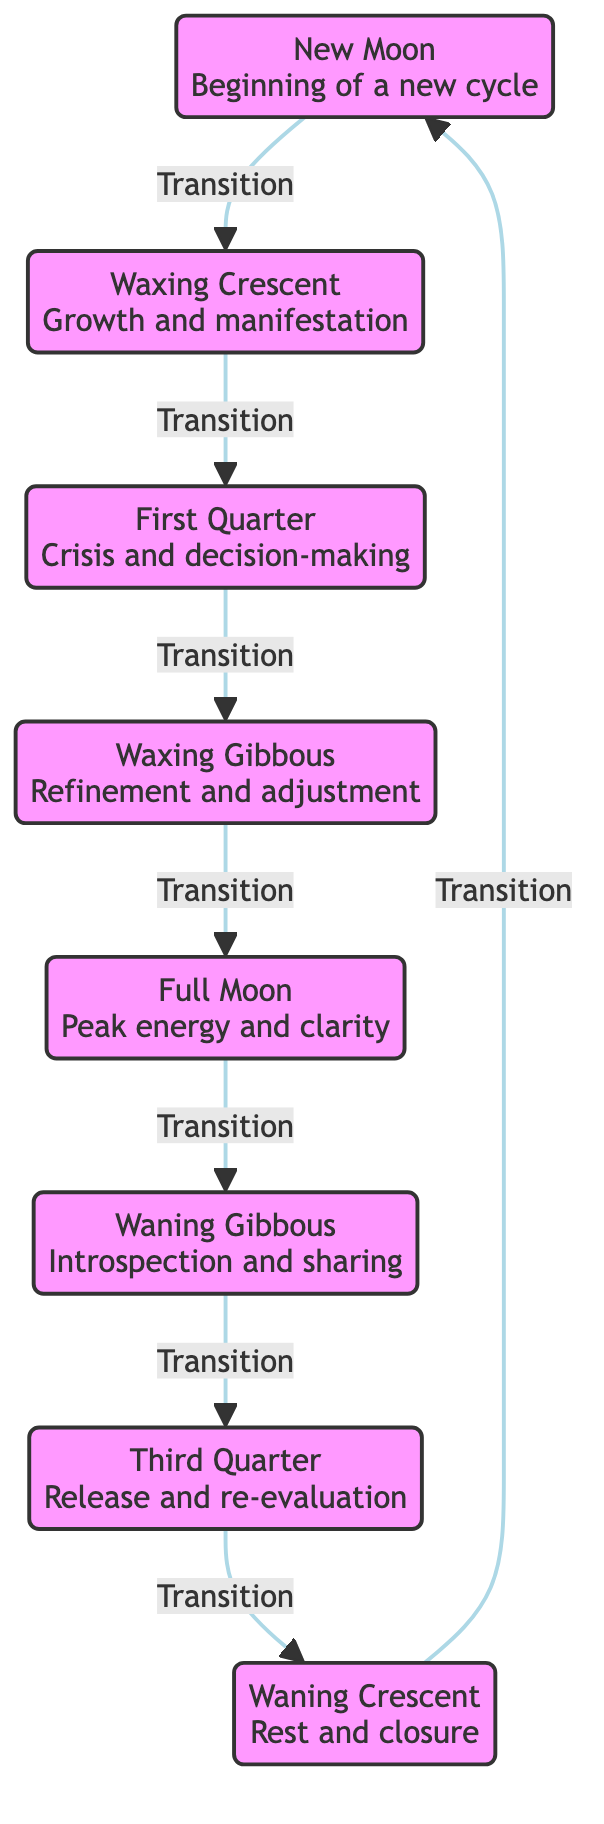What is the first phase of the Moon in the diagram? The diagram specifies the first phase of the Moon as "New Moon." This phase is explicitly labeled at the beginning of the transition sequence.
Answer: New Moon How many phases of the Moon are represented in the diagram? The diagram clearly shows eight phases of the Moon, which are listed in sequential order from New Moon to Waning Crescent.
Answer: Eight What phase follows the Full Moon? The Full Moon is followed by the "Waning Gibbous" phase in the diagram, indicated by the transition arrow pointing towards it.
Answer: Waning Gibbous What is the significance of the Waxing Crescent phase? The diagram indicates that the Waxing Crescent phase represents "Growth and manifestation," providing a specific meaning associated with this phase.
Answer: Growth and manifestation What phase represents introspection and sharing? The "Waning Gibbous" phase is associated with "Introspection and sharing," as described in the diagram connected to that phase.
Answer: Waning Gibbous What key event occurs during the First Quarter phase? During the First Quarter phase, the diagram notes "Crisis and decision-making," indicating a significant turning point in the Moon cycle.
Answer: Crisis and decision-making Which phase comes before the Waning Crescent? The phase preceding the Waning Crescent is the "Third Quarter," as indicated in the flow of transitions displayed in the diagram.
Answer: Third Quarter Which transition signifies the conclusion of the Moon's cycle? The transition from the Waning Crescent back to the New Moon signifies the conclusion of the Moon's cycle, as shown by the arrow leading back to the starting point.
Answer: New Moon 